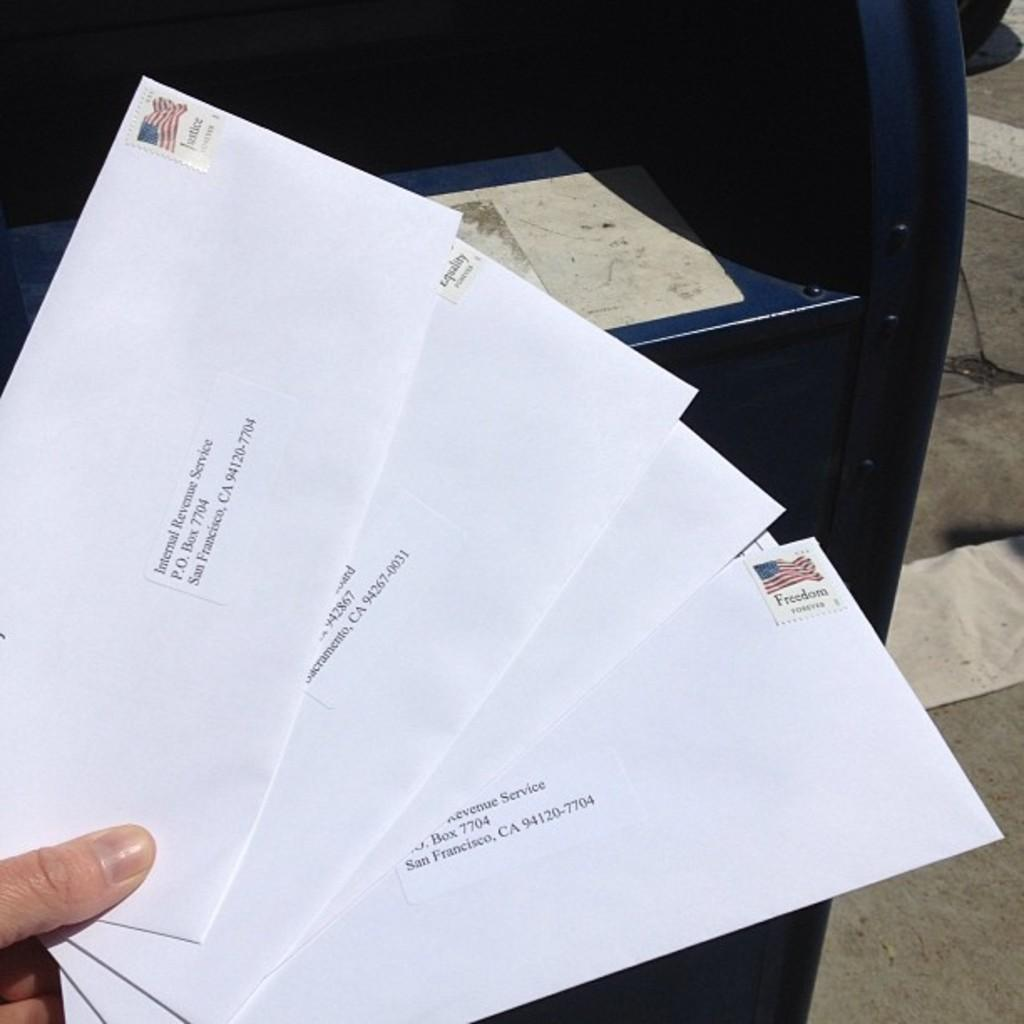<image>
Provide a brief description of the given image. A person is holding for envelopes addressed to San Francisco, CA. 